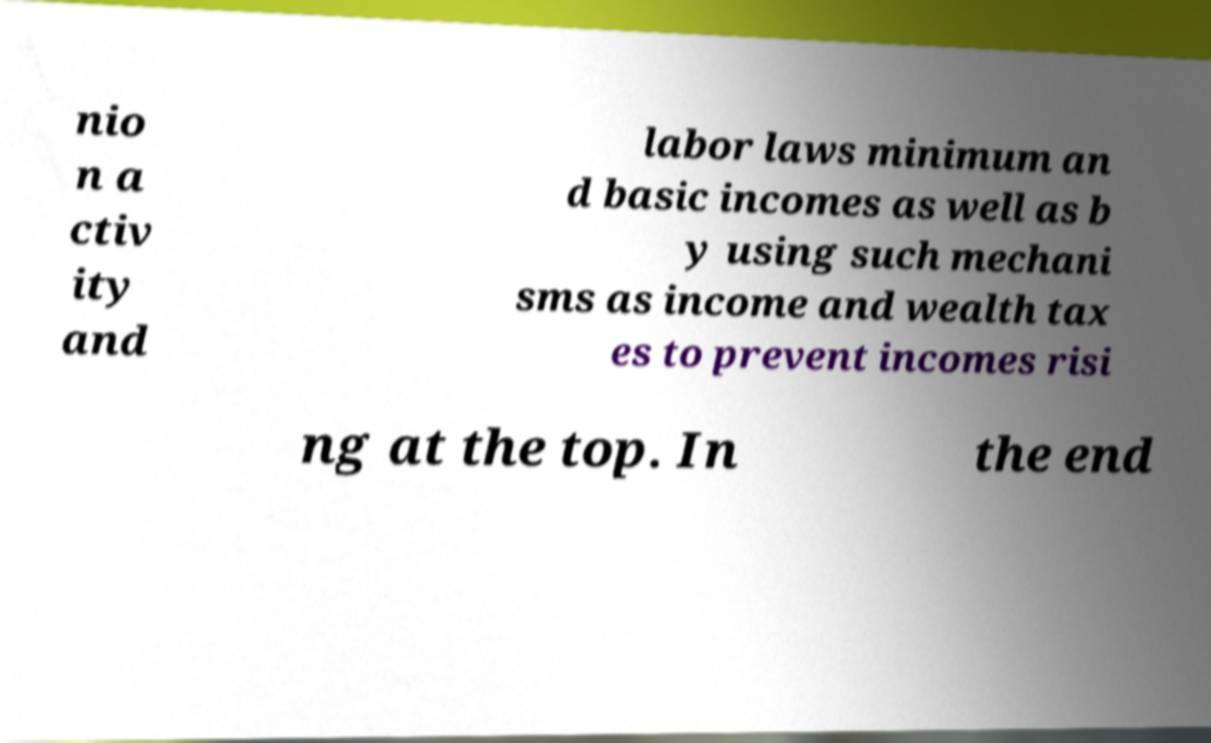I need the written content from this picture converted into text. Can you do that? nio n a ctiv ity and labor laws minimum an d basic incomes as well as b y using such mechani sms as income and wealth tax es to prevent incomes risi ng at the top. In the end 